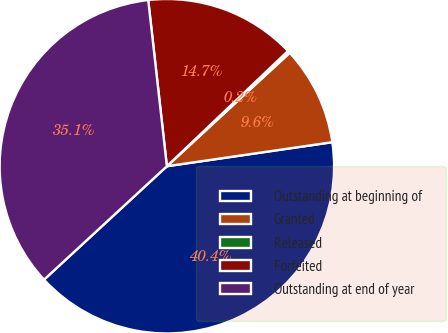Convert chart to OTSL. <chart><loc_0><loc_0><loc_500><loc_500><pie_chart><fcel>Outstanding at beginning of<fcel>Granted<fcel>Released<fcel>Forfeited<fcel>Outstanding at end of year<nl><fcel>40.43%<fcel>9.57%<fcel>0.24%<fcel>14.67%<fcel>35.09%<nl></chart> 